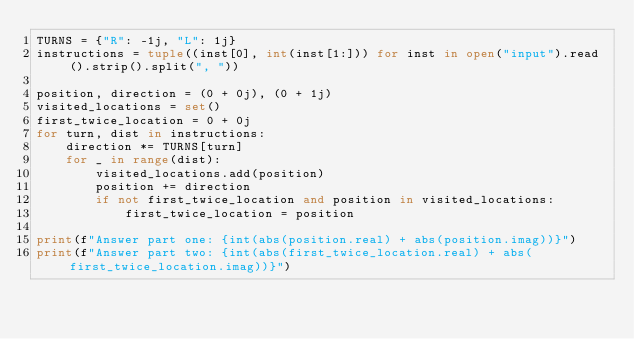<code> <loc_0><loc_0><loc_500><loc_500><_Python_>TURNS = {"R": -1j, "L": 1j}
instructions = tuple((inst[0], int(inst[1:])) for inst in open("input").read().strip().split(", "))

position, direction = (0 + 0j), (0 + 1j)
visited_locations = set()
first_twice_location = 0 + 0j
for turn, dist in instructions:
    direction *= TURNS[turn]
    for _ in range(dist):
        visited_locations.add(position)
        position += direction
        if not first_twice_location and position in visited_locations:
            first_twice_location = position

print(f"Answer part one: {int(abs(position.real) + abs(position.imag))}")
print(f"Answer part two: {int(abs(first_twice_location.real) + abs(first_twice_location.imag))}")
</code> 